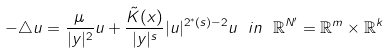<formula> <loc_0><loc_0><loc_500><loc_500>- \triangle u = \frac { \mu } { | y | ^ { 2 } } u + \frac { \tilde { K } ( x ) } { | y | ^ { s } } | u | ^ { 2 ^ { * } ( s ) - 2 } u \ i n \ \mathbb { R } ^ { N ^ { \prime } } = \mathbb { R } ^ { m } \times \mathbb { R } ^ { k }</formula> 